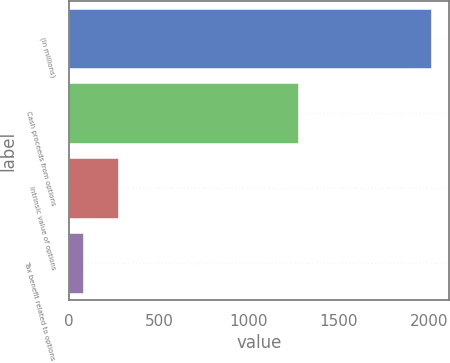Convert chart. <chart><loc_0><loc_0><loc_500><loc_500><bar_chart><fcel>(in millions)<fcel>Cash proceeds from options<fcel>Intrinsic value of options<fcel>Tax benefit related to options<nl><fcel>2014<fcel>1273<fcel>271.6<fcel>78<nl></chart> 